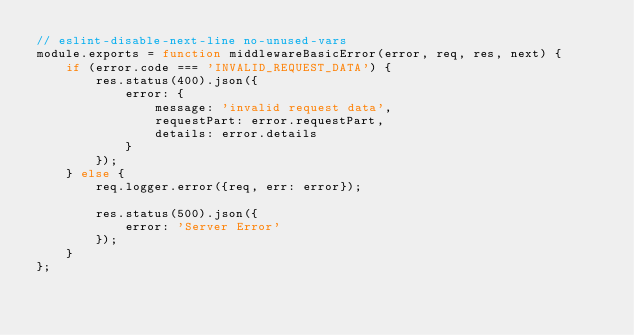<code> <loc_0><loc_0><loc_500><loc_500><_JavaScript_>// eslint-disable-next-line no-unused-vars
module.exports = function middlewareBasicError(error, req, res, next) {
    if (error.code === 'INVALID_REQUEST_DATA') {
        res.status(400).json({
            error: {
                message: 'invalid request data',
                requestPart: error.requestPart,
                details: error.details
            }
        });
    } else {
        req.logger.error({req, err: error});

        res.status(500).json({
            error: 'Server Error'
        });
    }
};
</code> 